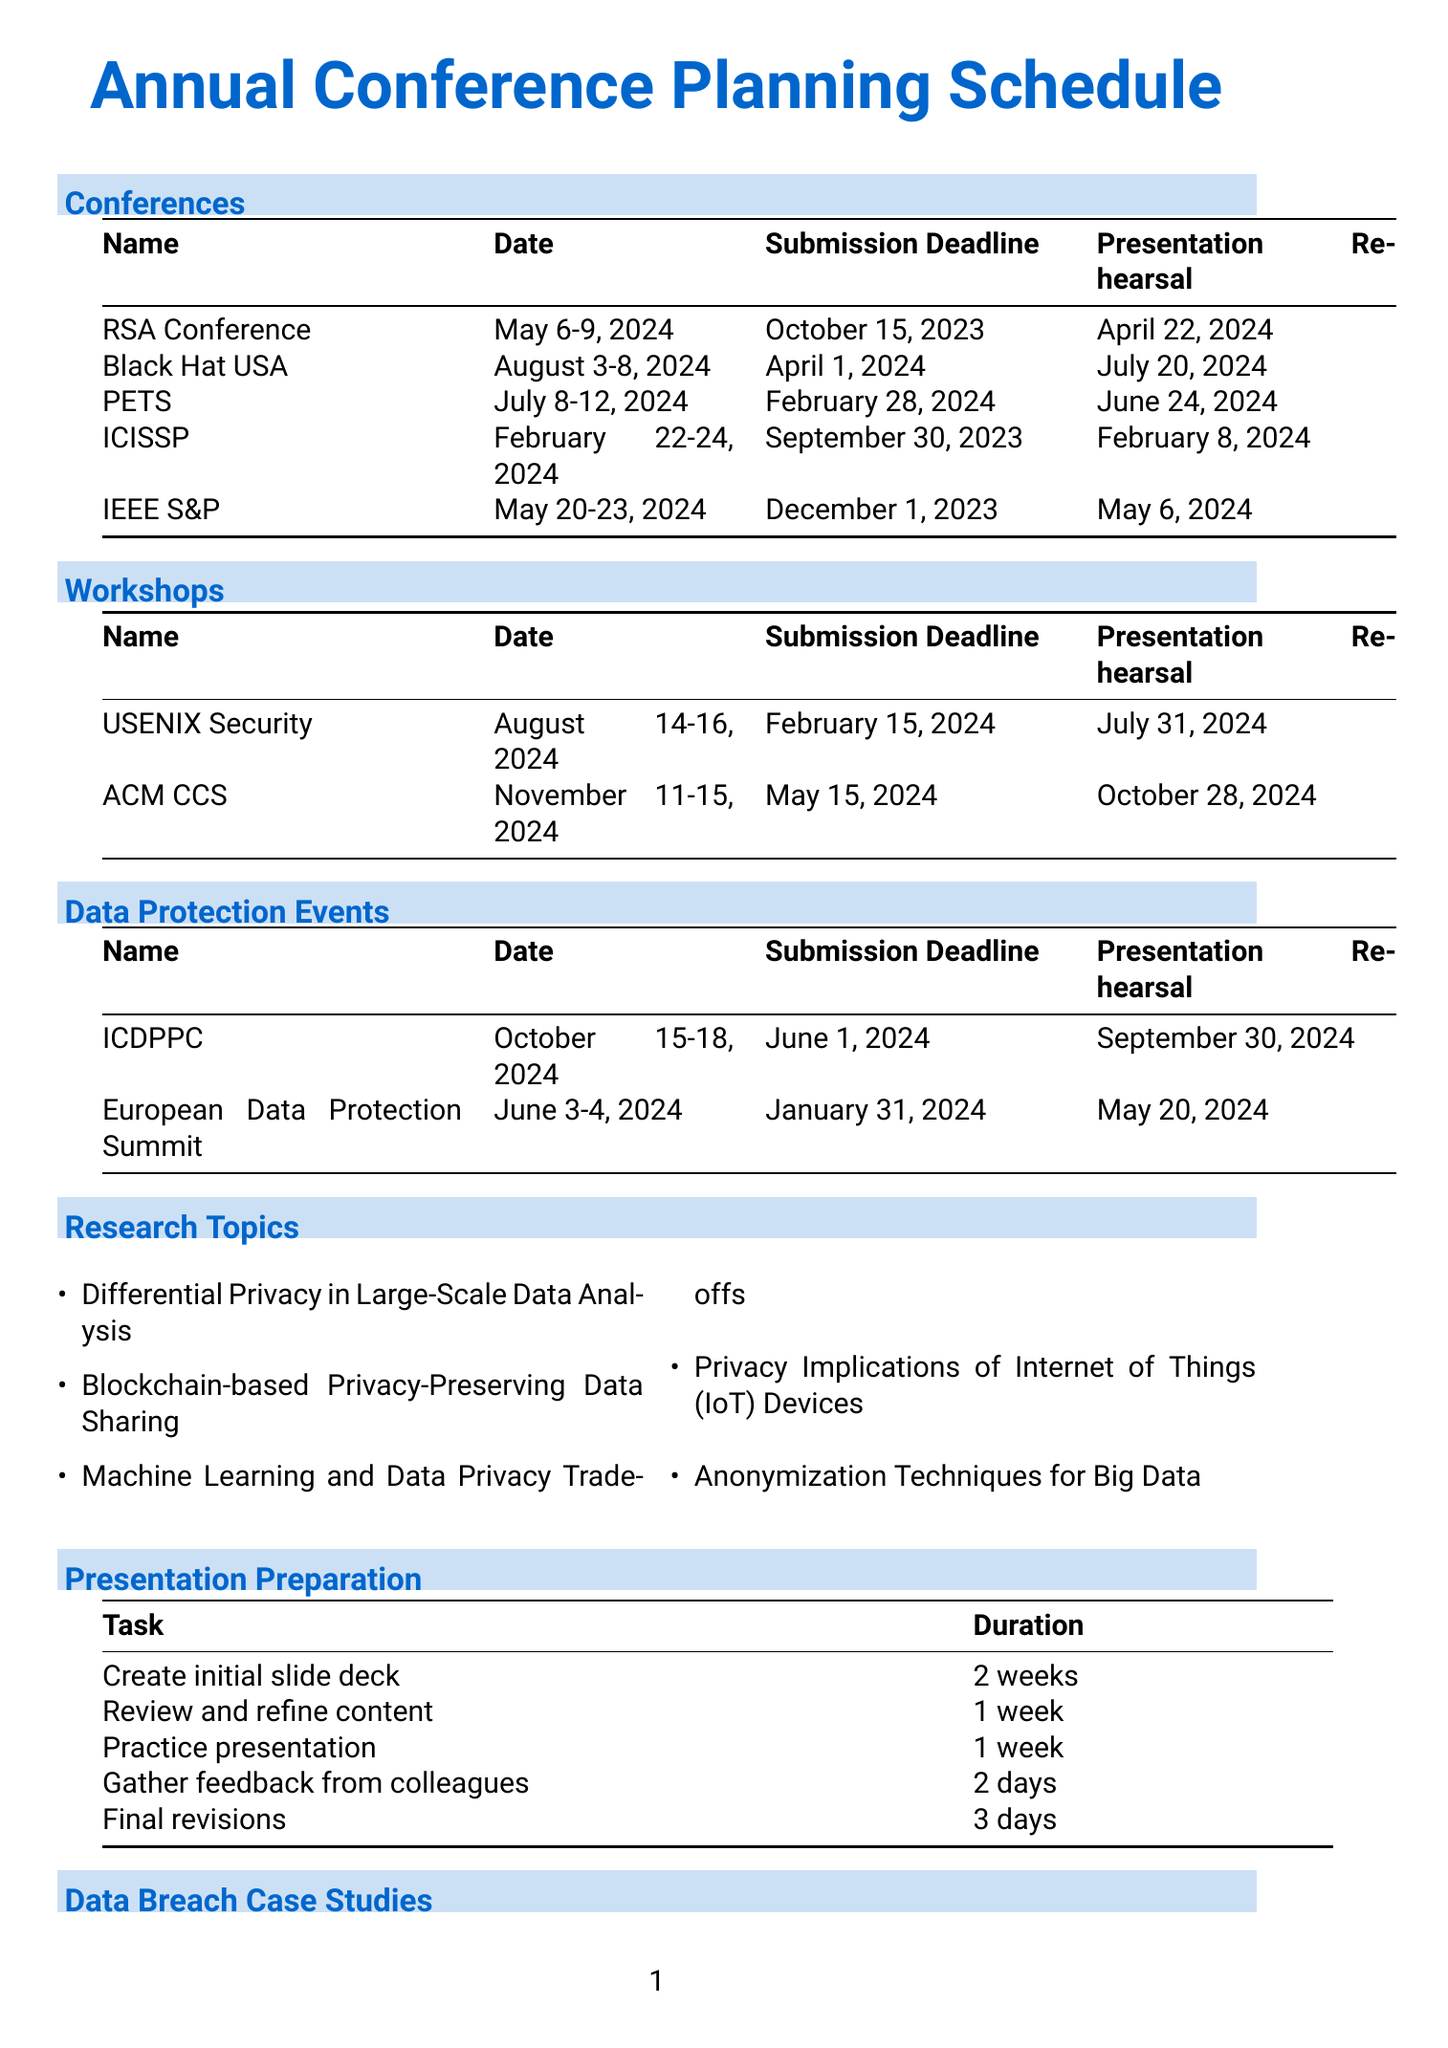What are the dates for the RSA Conference? The document lists the dates for the RSA Conference as May 6-9, 2024.
Answer: May 6-9, 2024 What is the submission deadline for the International Conference on Data Protection and Privacy Commissioners? According to the schedule, the submission deadline for the ICDPPC is June 1, 2024.
Answer: June 1, 2024 Where will the Black Hat USA conference be held? The location for the Black Hat USA conference is stated as Las Vegas, NV.
Answer: Las Vegas, NV When is the presentation rehearsal for the IEEE Symposium on Security and Privacy? The presentation rehearsal for the IEEE Symposium on Security and Privacy is scheduled for May 6, 2024.
Answer: May 6, 2024 How many research topics are listed in the document? There are five research topics provided in the document.
Answer: Five Which workshop has the earliest submission deadline? The workshop with the earliest submission deadline is the USENIX Security Symposium, with a deadline of February 15, 2024.
Answer: USENIX Security Symposium What is the total duration for creating the initial slide deck and practicing the presentation? The total duration is the sum of the two tasks: 2 weeks for the slide deck and 1 week for practicing, which equals 3 weeks.
Answer: 3 weeks What is the date of the European Data Protection Summit? The date listed for the European Data Protection Summit is June 3-4, 2024.
Answer: June 3-4, 2024 Which of the listed conferences has a presentation rehearsal date closest to the submission deadline? The conference ICISSP has a presentation rehearsal on February 8, 2024, which is closest to its submission deadline of September 30, 2023.
Answer: ICISSP 